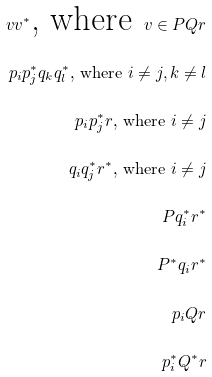<formula> <loc_0><loc_0><loc_500><loc_500>v v ^ { \ast } \text {, where } v \in P Q r \\ p _ { i } p _ { j } ^ { \ast } q _ { k } q _ { l } ^ { \ast } \text {, where } i \neq j , k \neq l \\ p _ { i } p _ { j } ^ { \ast } r \text {, where } i \neq j \\ q _ { i } q _ { j } ^ { \ast } r ^ { \ast } \text {, where } i \neq j \\ P q _ { i } ^ { \ast } r ^ { \ast } \\ P ^ { \ast } q _ { i } r ^ { \ast } \\ p _ { i } Q r \\ p _ { i } ^ { \ast } Q ^ { \ast } r</formula> 